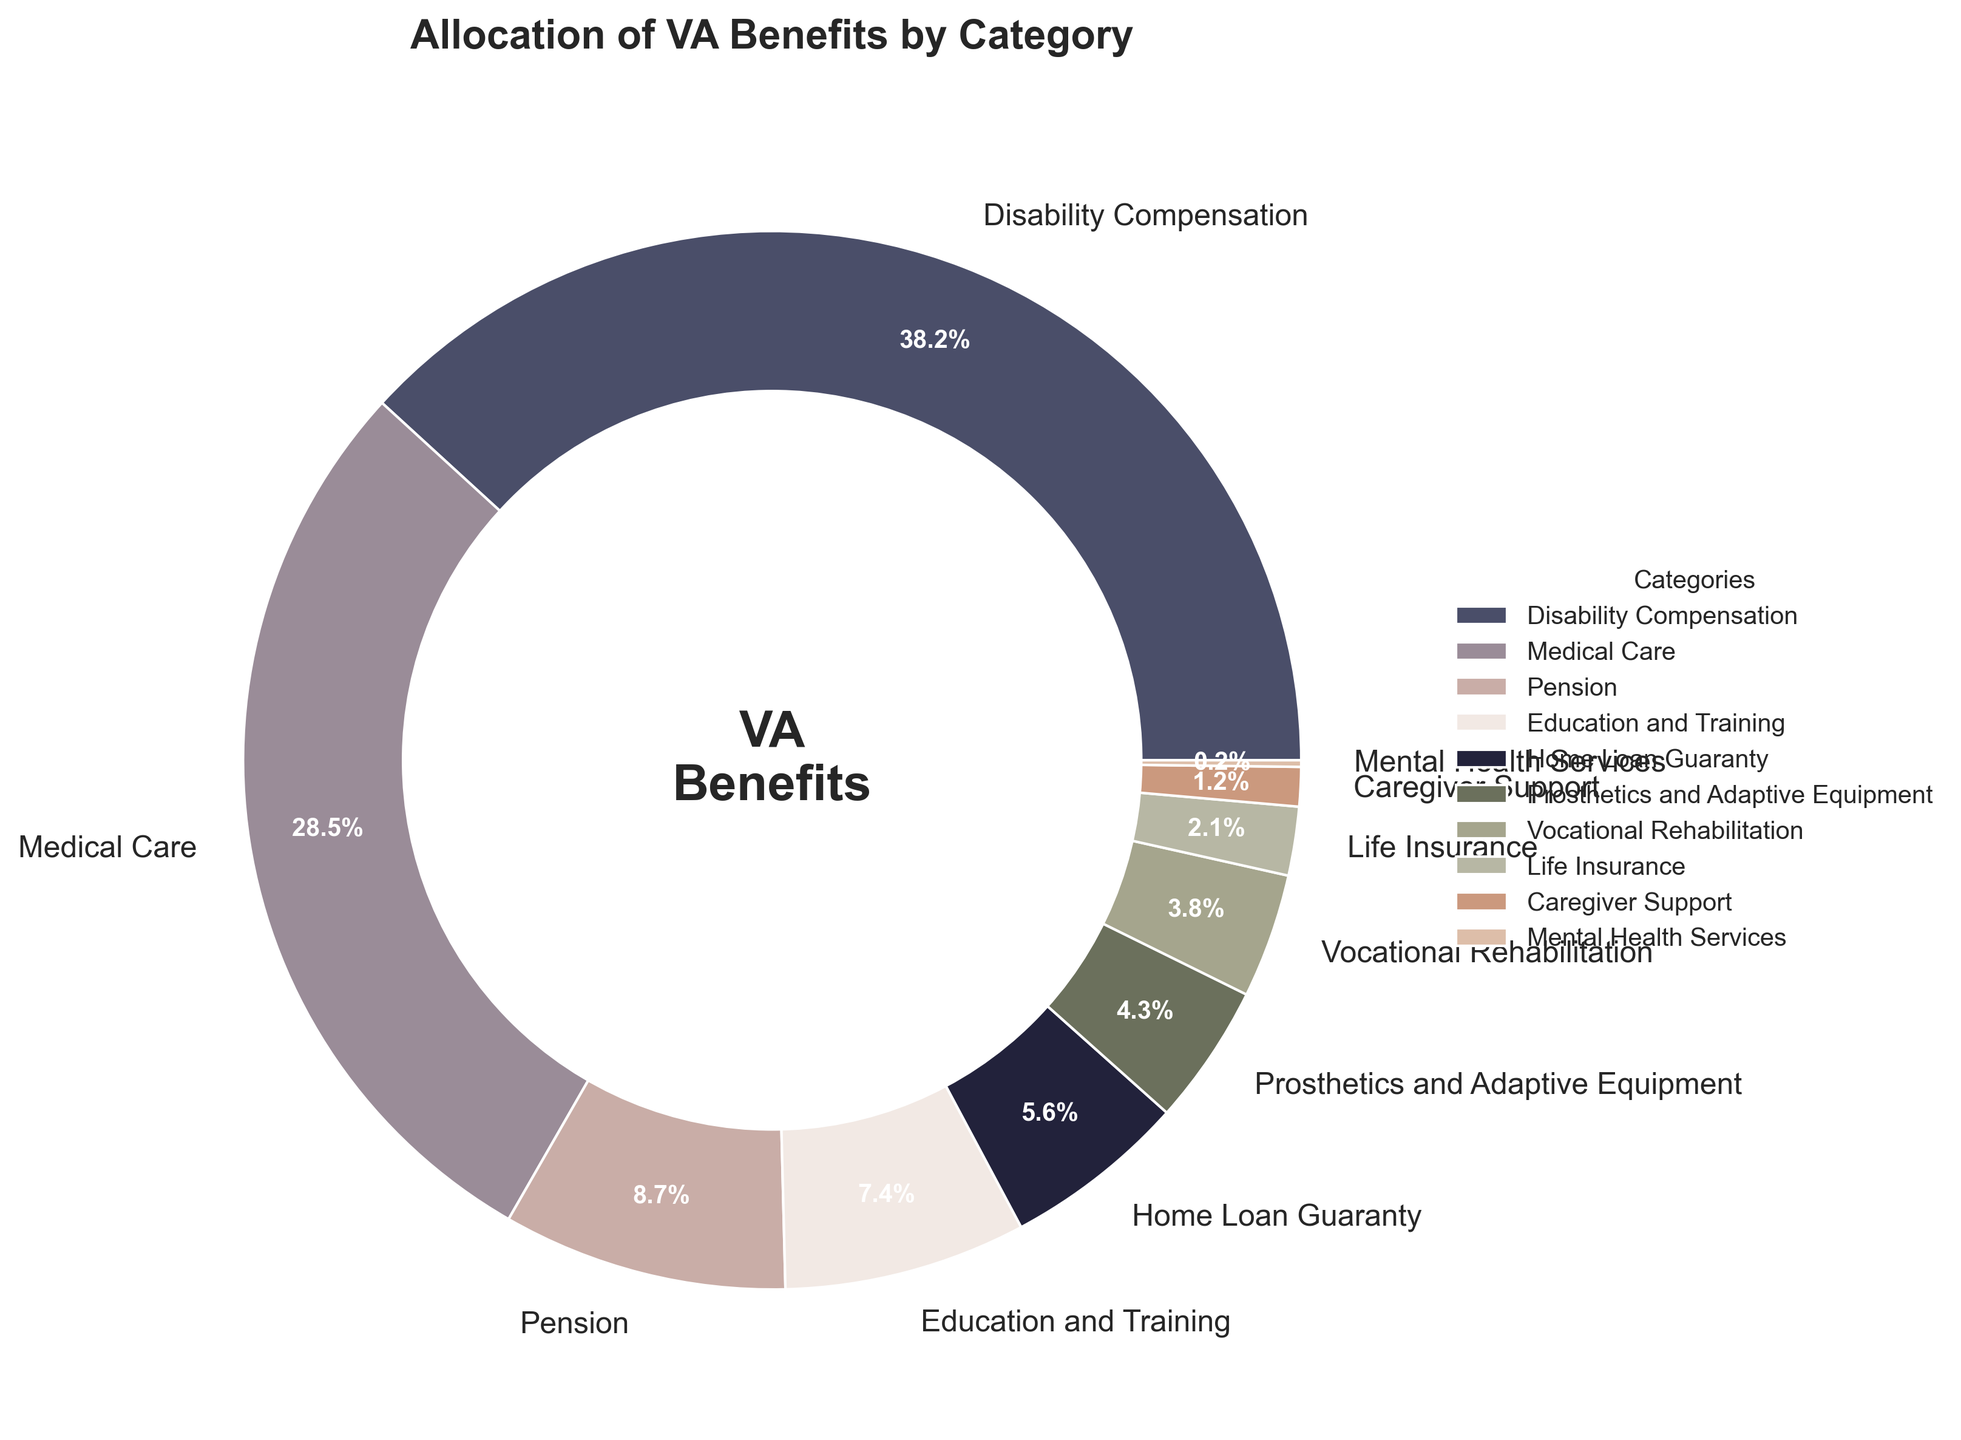Which category receives the highest percentage of allocation? Look at the chart and identify the category with the largest slice. "Disability Compensation" has 38.2%, which is the highest.
Answer: Disability Compensation By how many percentage points does the allocation for Medical Care exceed that for Education and Training? Identify the percentages for Medical Care (28.5%) and Education and Training (7.4%). Subtract the smaller percentage from the larger one: 28.5 - 7.4 = 21.1.
Answer: 21.1 What is the combined allocation percentage for Pension, Home Loan Guaranty, and Life Insurance? Identify the percentages for Pension (8.7%), Home Loan Guaranty (5.6%), and Life Insurance (2.1%). Add them together: 8.7 + 5.6 + 2.1 = 16.4.
Answer: 16.4 Is the percentage allocated to Vocational Rehabilitation greater than that for Prosthetics and Adaptive Equipment? Compare the percentage for Vocational Rehabilitation (3.8%) with that for Prosthetics and Adaptive Equipment (4.3%). No, 3.8% is not greater than 4.3%.
Answer: No How does the percentage allocated to Caregiver Support compare to that for Mental Health Services? Carefully examine the chart for the two categories. Caregiver Support is allocated 1.2% and Mental Health Services is allocated 0.2%. 1.2% is greater than 0.2%.
Answer: Caregiver Support is greater What is the difference in the allocation percentage between Disability Compensation and Home Loan Guaranty? Identify the percentages for Disability Compensation (38.2%) and Home Loan Guaranty (5.6%). Subtract the smaller percentage from the larger one: 38.2 - 5.6 = 32.6.
Answer: 32.6 Which category is allocated more, Prosthetics and Adaptive Equipment or Vocational Rehabilitation? Compare the percentages for Prosthetics and Adaptive Equipment (4.3%) and Vocational Rehabilitation (3.8%). 4.3% is greater than 3.8%.
Answer: Prosthetics and Adaptive Equipment What is the total percentage for the categories allocated less than 5%? Identify the categories: Home Loan Guaranty (5.6%), Prosthetics and Adaptive Equipment (4.3%), Vocational Rehabilitation (3.8%), Life Insurance (2.1%), Caregiver Support (1.2%), and Mental Health Services (0.2%). Sum the ones below 5%: 4.3 + 3.8 + 2.1 + 1.2 + 0.2 = 11.6.
Answer: 11.6 What percentage of the total allocation is spent on medical-related categories (Medical Care, Mental Health Services, and Prosthetics & Adaptive Equipment)? Add the allocations for Medical Care (28.5%), Mental Health Services (0.2%), and Prosthetics and Adaptive Equipment (4.3%). 28.5 + 0.2 + 4.3 = 33.0.
Answer: 33.0 Is the sum of percentages for Education and Training and Mental Health Services less than 10%? Identify the percentages for Education and Training (7.4%) and Mental Health Services (0.2%). Add the values: 7.4 + 0.2 = 7.6, which is less than 10%.
Answer: Yes 